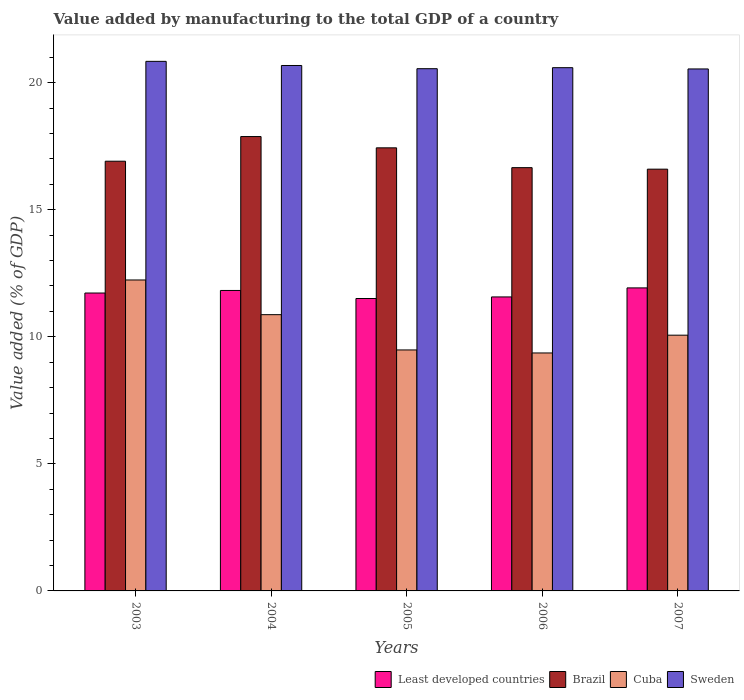How many different coloured bars are there?
Offer a very short reply. 4. Are the number of bars per tick equal to the number of legend labels?
Your answer should be very brief. Yes. Are the number of bars on each tick of the X-axis equal?
Provide a short and direct response. Yes. What is the label of the 4th group of bars from the left?
Provide a succinct answer. 2006. What is the value added by manufacturing to the total GDP in Brazil in 2006?
Provide a short and direct response. 16.65. Across all years, what is the maximum value added by manufacturing to the total GDP in Least developed countries?
Offer a terse response. 11.92. Across all years, what is the minimum value added by manufacturing to the total GDP in Sweden?
Provide a succinct answer. 20.54. What is the total value added by manufacturing to the total GDP in Least developed countries in the graph?
Your response must be concise. 58.54. What is the difference between the value added by manufacturing to the total GDP in Brazil in 2004 and that in 2006?
Provide a short and direct response. 1.22. What is the difference between the value added by manufacturing to the total GDP in Brazil in 2006 and the value added by manufacturing to the total GDP in Cuba in 2004?
Provide a succinct answer. 5.78. What is the average value added by manufacturing to the total GDP in Cuba per year?
Your answer should be very brief. 10.4. In the year 2007, what is the difference between the value added by manufacturing to the total GDP in Least developed countries and value added by manufacturing to the total GDP in Cuba?
Provide a short and direct response. 1.86. In how many years, is the value added by manufacturing to the total GDP in Cuba greater than 10 %?
Give a very brief answer. 3. What is the ratio of the value added by manufacturing to the total GDP in Cuba in 2005 to that in 2006?
Offer a terse response. 1.01. Is the value added by manufacturing to the total GDP in Cuba in 2005 less than that in 2007?
Ensure brevity in your answer.  Yes. What is the difference between the highest and the second highest value added by manufacturing to the total GDP in Sweden?
Give a very brief answer. 0.16. What is the difference between the highest and the lowest value added by manufacturing to the total GDP in Cuba?
Your answer should be compact. 2.87. In how many years, is the value added by manufacturing to the total GDP in Sweden greater than the average value added by manufacturing to the total GDP in Sweden taken over all years?
Give a very brief answer. 2. Is the sum of the value added by manufacturing to the total GDP in Least developed countries in 2003 and 2005 greater than the maximum value added by manufacturing to the total GDP in Brazil across all years?
Your answer should be very brief. Yes. What does the 3rd bar from the left in 2004 represents?
Offer a terse response. Cuba. What does the 4th bar from the right in 2006 represents?
Your answer should be compact. Least developed countries. Is it the case that in every year, the sum of the value added by manufacturing to the total GDP in Brazil and value added by manufacturing to the total GDP in Sweden is greater than the value added by manufacturing to the total GDP in Cuba?
Offer a terse response. Yes. How many bars are there?
Offer a very short reply. 20. Are the values on the major ticks of Y-axis written in scientific E-notation?
Your answer should be very brief. No. Does the graph contain grids?
Give a very brief answer. No. Where does the legend appear in the graph?
Your response must be concise. Bottom right. How many legend labels are there?
Offer a terse response. 4. How are the legend labels stacked?
Make the answer very short. Horizontal. What is the title of the graph?
Your response must be concise. Value added by manufacturing to the total GDP of a country. Does "Sierra Leone" appear as one of the legend labels in the graph?
Make the answer very short. No. What is the label or title of the Y-axis?
Your answer should be very brief. Value added (% of GDP). What is the Value added (% of GDP) in Least developed countries in 2003?
Ensure brevity in your answer.  11.72. What is the Value added (% of GDP) in Brazil in 2003?
Your response must be concise. 16.91. What is the Value added (% of GDP) in Cuba in 2003?
Make the answer very short. 12.23. What is the Value added (% of GDP) of Sweden in 2003?
Ensure brevity in your answer.  20.84. What is the Value added (% of GDP) of Least developed countries in 2004?
Provide a succinct answer. 11.82. What is the Value added (% of GDP) in Brazil in 2004?
Make the answer very short. 17.88. What is the Value added (% of GDP) of Cuba in 2004?
Ensure brevity in your answer.  10.87. What is the Value added (% of GDP) in Sweden in 2004?
Make the answer very short. 20.67. What is the Value added (% of GDP) of Least developed countries in 2005?
Provide a succinct answer. 11.51. What is the Value added (% of GDP) in Brazil in 2005?
Keep it short and to the point. 17.43. What is the Value added (% of GDP) in Cuba in 2005?
Ensure brevity in your answer.  9.48. What is the Value added (% of GDP) in Sweden in 2005?
Ensure brevity in your answer.  20.55. What is the Value added (% of GDP) in Least developed countries in 2006?
Offer a terse response. 11.57. What is the Value added (% of GDP) in Brazil in 2006?
Your answer should be compact. 16.65. What is the Value added (% of GDP) in Cuba in 2006?
Ensure brevity in your answer.  9.36. What is the Value added (% of GDP) of Sweden in 2006?
Keep it short and to the point. 20.59. What is the Value added (% of GDP) of Least developed countries in 2007?
Make the answer very short. 11.92. What is the Value added (% of GDP) in Brazil in 2007?
Keep it short and to the point. 16.59. What is the Value added (% of GDP) in Cuba in 2007?
Provide a succinct answer. 10.06. What is the Value added (% of GDP) of Sweden in 2007?
Offer a terse response. 20.54. Across all years, what is the maximum Value added (% of GDP) in Least developed countries?
Offer a very short reply. 11.92. Across all years, what is the maximum Value added (% of GDP) in Brazil?
Provide a succinct answer. 17.88. Across all years, what is the maximum Value added (% of GDP) in Cuba?
Make the answer very short. 12.23. Across all years, what is the maximum Value added (% of GDP) of Sweden?
Your response must be concise. 20.84. Across all years, what is the minimum Value added (% of GDP) of Least developed countries?
Provide a succinct answer. 11.51. Across all years, what is the minimum Value added (% of GDP) in Brazil?
Ensure brevity in your answer.  16.59. Across all years, what is the minimum Value added (% of GDP) in Cuba?
Your answer should be very brief. 9.36. Across all years, what is the minimum Value added (% of GDP) in Sweden?
Keep it short and to the point. 20.54. What is the total Value added (% of GDP) of Least developed countries in the graph?
Offer a terse response. 58.54. What is the total Value added (% of GDP) in Brazil in the graph?
Give a very brief answer. 85.46. What is the total Value added (% of GDP) in Cuba in the graph?
Keep it short and to the point. 52.01. What is the total Value added (% of GDP) of Sweden in the graph?
Keep it short and to the point. 103.18. What is the difference between the Value added (% of GDP) of Least developed countries in 2003 and that in 2004?
Give a very brief answer. -0.1. What is the difference between the Value added (% of GDP) in Brazil in 2003 and that in 2004?
Your answer should be very brief. -0.97. What is the difference between the Value added (% of GDP) in Cuba in 2003 and that in 2004?
Your answer should be compact. 1.36. What is the difference between the Value added (% of GDP) of Sweden in 2003 and that in 2004?
Give a very brief answer. 0.16. What is the difference between the Value added (% of GDP) in Least developed countries in 2003 and that in 2005?
Keep it short and to the point. 0.22. What is the difference between the Value added (% of GDP) in Brazil in 2003 and that in 2005?
Your response must be concise. -0.53. What is the difference between the Value added (% of GDP) in Cuba in 2003 and that in 2005?
Offer a very short reply. 2.75. What is the difference between the Value added (% of GDP) in Sweden in 2003 and that in 2005?
Offer a very short reply. 0.29. What is the difference between the Value added (% of GDP) in Least developed countries in 2003 and that in 2006?
Your answer should be very brief. 0.15. What is the difference between the Value added (% of GDP) in Brazil in 2003 and that in 2006?
Keep it short and to the point. 0.25. What is the difference between the Value added (% of GDP) in Cuba in 2003 and that in 2006?
Keep it short and to the point. 2.87. What is the difference between the Value added (% of GDP) of Sweden in 2003 and that in 2006?
Make the answer very short. 0.25. What is the difference between the Value added (% of GDP) of Least developed countries in 2003 and that in 2007?
Ensure brevity in your answer.  -0.2. What is the difference between the Value added (% of GDP) in Brazil in 2003 and that in 2007?
Make the answer very short. 0.31. What is the difference between the Value added (% of GDP) in Cuba in 2003 and that in 2007?
Provide a succinct answer. 2.17. What is the difference between the Value added (% of GDP) of Sweden in 2003 and that in 2007?
Ensure brevity in your answer.  0.3. What is the difference between the Value added (% of GDP) of Least developed countries in 2004 and that in 2005?
Provide a succinct answer. 0.32. What is the difference between the Value added (% of GDP) in Brazil in 2004 and that in 2005?
Make the answer very short. 0.44. What is the difference between the Value added (% of GDP) of Cuba in 2004 and that in 2005?
Offer a terse response. 1.39. What is the difference between the Value added (% of GDP) of Sweden in 2004 and that in 2005?
Keep it short and to the point. 0.13. What is the difference between the Value added (% of GDP) of Least developed countries in 2004 and that in 2006?
Provide a short and direct response. 0.25. What is the difference between the Value added (% of GDP) in Brazil in 2004 and that in 2006?
Keep it short and to the point. 1.22. What is the difference between the Value added (% of GDP) of Cuba in 2004 and that in 2006?
Keep it short and to the point. 1.51. What is the difference between the Value added (% of GDP) in Sweden in 2004 and that in 2006?
Ensure brevity in your answer.  0.09. What is the difference between the Value added (% of GDP) in Least developed countries in 2004 and that in 2007?
Ensure brevity in your answer.  -0.1. What is the difference between the Value added (% of GDP) in Brazil in 2004 and that in 2007?
Provide a succinct answer. 1.28. What is the difference between the Value added (% of GDP) in Cuba in 2004 and that in 2007?
Provide a succinct answer. 0.81. What is the difference between the Value added (% of GDP) of Sweden in 2004 and that in 2007?
Provide a succinct answer. 0.14. What is the difference between the Value added (% of GDP) of Least developed countries in 2005 and that in 2006?
Keep it short and to the point. -0.06. What is the difference between the Value added (% of GDP) in Brazil in 2005 and that in 2006?
Your response must be concise. 0.78. What is the difference between the Value added (% of GDP) in Cuba in 2005 and that in 2006?
Provide a short and direct response. 0.12. What is the difference between the Value added (% of GDP) of Sweden in 2005 and that in 2006?
Make the answer very short. -0.04. What is the difference between the Value added (% of GDP) in Least developed countries in 2005 and that in 2007?
Your answer should be very brief. -0.42. What is the difference between the Value added (% of GDP) of Brazil in 2005 and that in 2007?
Keep it short and to the point. 0.84. What is the difference between the Value added (% of GDP) in Cuba in 2005 and that in 2007?
Keep it short and to the point. -0.58. What is the difference between the Value added (% of GDP) of Sweden in 2005 and that in 2007?
Offer a terse response. 0.01. What is the difference between the Value added (% of GDP) of Least developed countries in 2006 and that in 2007?
Make the answer very short. -0.36. What is the difference between the Value added (% of GDP) of Brazil in 2006 and that in 2007?
Provide a short and direct response. 0.06. What is the difference between the Value added (% of GDP) of Cuba in 2006 and that in 2007?
Offer a terse response. -0.7. What is the difference between the Value added (% of GDP) in Sweden in 2006 and that in 2007?
Ensure brevity in your answer.  0.05. What is the difference between the Value added (% of GDP) of Least developed countries in 2003 and the Value added (% of GDP) of Brazil in 2004?
Provide a short and direct response. -6.16. What is the difference between the Value added (% of GDP) of Least developed countries in 2003 and the Value added (% of GDP) of Cuba in 2004?
Make the answer very short. 0.85. What is the difference between the Value added (% of GDP) of Least developed countries in 2003 and the Value added (% of GDP) of Sweden in 2004?
Your response must be concise. -8.95. What is the difference between the Value added (% of GDP) in Brazil in 2003 and the Value added (% of GDP) in Cuba in 2004?
Provide a short and direct response. 6.04. What is the difference between the Value added (% of GDP) of Brazil in 2003 and the Value added (% of GDP) of Sweden in 2004?
Offer a very short reply. -3.77. What is the difference between the Value added (% of GDP) in Cuba in 2003 and the Value added (% of GDP) in Sweden in 2004?
Offer a terse response. -8.44. What is the difference between the Value added (% of GDP) of Least developed countries in 2003 and the Value added (% of GDP) of Brazil in 2005?
Keep it short and to the point. -5.71. What is the difference between the Value added (% of GDP) of Least developed countries in 2003 and the Value added (% of GDP) of Cuba in 2005?
Your response must be concise. 2.24. What is the difference between the Value added (% of GDP) in Least developed countries in 2003 and the Value added (% of GDP) in Sweden in 2005?
Make the answer very short. -8.83. What is the difference between the Value added (% of GDP) in Brazil in 2003 and the Value added (% of GDP) in Cuba in 2005?
Keep it short and to the point. 7.43. What is the difference between the Value added (% of GDP) of Brazil in 2003 and the Value added (% of GDP) of Sweden in 2005?
Your answer should be compact. -3.64. What is the difference between the Value added (% of GDP) of Cuba in 2003 and the Value added (% of GDP) of Sweden in 2005?
Keep it short and to the point. -8.31. What is the difference between the Value added (% of GDP) of Least developed countries in 2003 and the Value added (% of GDP) of Brazil in 2006?
Keep it short and to the point. -4.93. What is the difference between the Value added (% of GDP) in Least developed countries in 2003 and the Value added (% of GDP) in Cuba in 2006?
Provide a succinct answer. 2.36. What is the difference between the Value added (% of GDP) of Least developed countries in 2003 and the Value added (% of GDP) of Sweden in 2006?
Offer a terse response. -8.87. What is the difference between the Value added (% of GDP) of Brazil in 2003 and the Value added (% of GDP) of Cuba in 2006?
Keep it short and to the point. 7.54. What is the difference between the Value added (% of GDP) in Brazil in 2003 and the Value added (% of GDP) in Sweden in 2006?
Your answer should be very brief. -3.68. What is the difference between the Value added (% of GDP) in Cuba in 2003 and the Value added (% of GDP) in Sweden in 2006?
Ensure brevity in your answer.  -8.35. What is the difference between the Value added (% of GDP) in Least developed countries in 2003 and the Value added (% of GDP) in Brazil in 2007?
Provide a short and direct response. -4.87. What is the difference between the Value added (% of GDP) in Least developed countries in 2003 and the Value added (% of GDP) in Cuba in 2007?
Ensure brevity in your answer.  1.66. What is the difference between the Value added (% of GDP) in Least developed countries in 2003 and the Value added (% of GDP) in Sweden in 2007?
Make the answer very short. -8.82. What is the difference between the Value added (% of GDP) of Brazil in 2003 and the Value added (% of GDP) of Cuba in 2007?
Provide a short and direct response. 6.84. What is the difference between the Value added (% of GDP) in Brazil in 2003 and the Value added (% of GDP) in Sweden in 2007?
Provide a succinct answer. -3.63. What is the difference between the Value added (% of GDP) in Cuba in 2003 and the Value added (% of GDP) in Sweden in 2007?
Your answer should be compact. -8.3. What is the difference between the Value added (% of GDP) in Least developed countries in 2004 and the Value added (% of GDP) in Brazil in 2005?
Provide a succinct answer. -5.61. What is the difference between the Value added (% of GDP) in Least developed countries in 2004 and the Value added (% of GDP) in Cuba in 2005?
Give a very brief answer. 2.34. What is the difference between the Value added (% of GDP) of Least developed countries in 2004 and the Value added (% of GDP) of Sweden in 2005?
Make the answer very short. -8.73. What is the difference between the Value added (% of GDP) of Brazil in 2004 and the Value added (% of GDP) of Cuba in 2005?
Your answer should be compact. 8.4. What is the difference between the Value added (% of GDP) of Brazil in 2004 and the Value added (% of GDP) of Sweden in 2005?
Provide a short and direct response. -2.67. What is the difference between the Value added (% of GDP) in Cuba in 2004 and the Value added (% of GDP) in Sweden in 2005?
Offer a very short reply. -9.68. What is the difference between the Value added (% of GDP) of Least developed countries in 2004 and the Value added (% of GDP) of Brazil in 2006?
Your response must be concise. -4.83. What is the difference between the Value added (% of GDP) in Least developed countries in 2004 and the Value added (% of GDP) in Cuba in 2006?
Ensure brevity in your answer.  2.46. What is the difference between the Value added (% of GDP) in Least developed countries in 2004 and the Value added (% of GDP) in Sweden in 2006?
Ensure brevity in your answer.  -8.77. What is the difference between the Value added (% of GDP) in Brazil in 2004 and the Value added (% of GDP) in Cuba in 2006?
Ensure brevity in your answer.  8.51. What is the difference between the Value added (% of GDP) in Brazil in 2004 and the Value added (% of GDP) in Sweden in 2006?
Your answer should be very brief. -2.71. What is the difference between the Value added (% of GDP) of Cuba in 2004 and the Value added (% of GDP) of Sweden in 2006?
Ensure brevity in your answer.  -9.72. What is the difference between the Value added (% of GDP) of Least developed countries in 2004 and the Value added (% of GDP) of Brazil in 2007?
Give a very brief answer. -4.77. What is the difference between the Value added (% of GDP) of Least developed countries in 2004 and the Value added (% of GDP) of Cuba in 2007?
Offer a terse response. 1.76. What is the difference between the Value added (% of GDP) of Least developed countries in 2004 and the Value added (% of GDP) of Sweden in 2007?
Make the answer very short. -8.72. What is the difference between the Value added (% of GDP) in Brazil in 2004 and the Value added (% of GDP) in Cuba in 2007?
Provide a succinct answer. 7.81. What is the difference between the Value added (% of GDP) in Brazil in 2004 and the Value added (% of GDP) in Sweden in 2007?
Provide a succinct answer. -2.66. What is the difference between the Value added (% of GDP) of Cuba in 2004 and the Value added (% of GDP) of Sweden in 2007?
Offer a very short reply. -9.67. What is the difference between the Value added (% of GDP) of Least developed countries in 2005 and the Value added (% of GDP) of Brazil in 2006?
Your answer should be very brief. -5.15. What is the difference between the Value added (% of GDP) of Least developed countries in 2005 and the Value added (% of GDP) of Cuba in 2006?
Your response must be concise. 2.14. What is the difference between the Value added (% of GDP) of Least developed countries in 2005 and the Value added (% of GDP) of Sweden in 2006?
Your response must be concise. -9.08. What is the difference between the Value added (% of GDP) of Brazil in 2005 and the Value added (% of GDP) of Cuba in 2006?
Give a very brief answer. 8.07. What is the difference between the Value added (% of GDP) of Brazil in 2005 and the Value added (% of GDP) of Sweden in 2006?
Offer a very short reply. -3.15. What is the difference between the Value added (% of GDP) of Cuba in 2005 and the Value added (% of GDP) of Sweden in 2006?
Your answer should be very brief. -11.11. What is the difference between the Value added (% of GDP) in Least developed countries in 2005 and the Value added (% of GDP) in Brazil in 2007?
Make the answer very short. -5.09. What is the difference between the Value added (% of GDP) in Least developed countries in 2005 and the Value added (% of GDP) in Cuba in 2007?
Give a very brief answer. 1.44. What is the difference between the Value added (% of GDP) in Least developed countries in 2005 and the Value added (% of GDP) in Sweden in 2007?
Give a very brief answer. -9.03. What is the difference between the Value added (% of GDP) of Brazil in 2005 and the Value added (% of GDP) of Cuba in 2007?
Provide a short and direct response. 7.37. What is the difference between the Value added (% of GDP) in Brazil in 2005 and the Value added (% of GDP) in Sweden in 2007?
Your answer should be compact. -3.1. What is the difference between the Value added (% of GDP) in Cuba in 2005 and the Value added (% of GDP) in Sweden in 2007?
Your answer should be very brief. -11.06. What is the difference between the Value added (% of GDP) of Least developed countries in 2006 and the Value added (% of GDP) of Brazil in 2007?
Offer a terse response. -5.03. What is the difference between the Value added (% of GDP) of Least developed countries in 2006 and the Value added (% of GDP) of Cuba in 2007?
Make the answer very short. 1.51. What is the difference between the Value added (% of GDP) in Least developed countries in 2006 and the Value added (% of GDP) in Sweden in 2007?
Make the answer very short. -8.97. What is the difference between the Value added (% of GDP) in Brazil in 2006 and the Value added (% of GDP) in Cuba in 2007?
Offer a terse response. 6.59. What is the difference between the Value added (% of GDP) in Brazil in 2006 and the Value added (% of GDP) in Sweden in 2007?
Ensure brevity in your answer.  -3.88. What is the difference between the Value added (% of GDP) of Cuba in 2006 and the Value added (% of GDP) of Sweden in 2007?
Give a very brief answer. -11.17. What is the average Value added (% of GDP) of Least developed countries per year?
Your answer should be compact. 11.71. What is the average Value added (% of GDP) of Brazil per year?
Provide a short and direct response. 17.09. What is the average Value added (% of GDP) in Cuba per year?
Offer a terse response. 10.4. What is the average Value added (% of GDP) in Sweden per year?
Offer a very short reply. 20.64. In the year 2003, what is the difference between the Value added (% of GDP) in Least developed countries and Value added (% of GDP) in Brazil?
Your answer should be very brief. -5.19. In the year 2003, what is the difference between the Value added (% of GDP) in Least developed countries and Value added (% of GDP) in Cuba?
Offer a terse response. -0.51. In the year 2003, what is the difference between the Value added (% of GDP) of Least developed countries and Value added (% of GDP) of Sweden?
Provide a succinct answer. -9.12. In the year 2003, what is the difference between the Value added (% of GDP) in Brazil and Value added (% of GDP) in Cuba?
Your answer should be compact. 4.67. In the year 2003, what is the difference between the Value added (% of GDP) in Brazil and Value added (% of GDP) in Sweden?
Provide a succinct answer. -3.93. In the year 2003, what is the difference between the Value added (% of GDP) in Cuba and Value added (% of GDP) in Sweden?
Offer a very short reply. -8.6. In the year 2004, what is the difference between the Value added (% of GDP) in Least developed countries and Value added (% of GDP) in Brazil?
Provide a short and direct response. -6.05. In the year 2004, what is the difference between the Value added (% of GDP) of Least developed countries and Value added (% of GDP) of Cuba?
Your answer should be compact. 0.95. In the year 2004, what is the difference between the Value added (% of GDP) of Least developed countries and Value added (% of GDP) of Sweden?
Make the answer very short. -8.85. In the year 2004, what is the difference between the Value added (% of GDP) in Brazil and Value added (% of GDP) in Cuba?
Keep it short and to the point. 7.01. In the year 2004, what is the difference between the Value added (% of GDP) of Brazil and Value added (% of GDP) of Sweden?
Provide a succinct answer. -2.8. In the year 2004, what is the difference between the Value added (% of GDP) of Cuba and Value added (% of GDP) of Sweden?
Offer a very short reply. -9.8. In the year 2005, what is the difference between the Value added (% of GDP) of Least developed countries and Value added (% of GDP) of Brazil?
Your answer should be very brief. -5.93. In the year 2005, what is the difference between the Value added (% of GDP) of Least developed countries and Value added (% of GDP) of Cuba?
Keep it short and to the point. 2.02. In the year 2005, what is the difference between the Value added (% of GDP) of Least developed countries and Value added (% of GDP) of Sweden?
Make the answer very short. -9.04. In the year 2005, what is the difference between the Value added (% of GDP) of Brazil and Value added (% of GDP) of Cuba?
Your answer should be very brief. 7.95. In the year 2005, what is the difference between the Value added (% of GDP) of Brazil and Value added (% of GDP) of Sweden?
Your answer should be compact. -3.11. In the year 2005, what is the difference between the Value added (% of GDP) in Cuba and Value added (% of GDP) in Sweden?
Your answer should be very brief. -11.07. In the year 2006, what is the difference between the Value added (% of GDP) in Least developed countries and Value added (% of GDP) in Brazil?
Your answer should be compact. -5.09. In the year 2006, what is the difference between the Value added (% of GDP) of Least developed countries and Value added (% of GDP) of Cuba?
Your response must be concise. 2.2. In the year 2006, what is the difference between the Value added (% of GDP) in Least developed countries and Value added (% of GDP) in Sweden?
Offer a terse response. -9.02. In the year 2006, what is the difference between the Value added (% of GDP) of Brazil and Value added (% of GDP) of Cuba?
Your answer should be very brief. 7.29. In the year 2006, what is the difference between the Value added (% of GDP) in Brazil and Value added (% of GDP) in Sweden?
Provide a short and direct response. -3.93. In the year 2006, what is the difference between the Value added (% of GDP) of Cuba and Value added (% of GDP) of Sweden?
Give a very brief answer. -11.22. In the year 2007, what is the difference between the Value added (% of GDP) in Least developed countries and Value added (% of GDP) in Brazil?
Your answer should be very brief. -4.67. In the year 2007, what is the difference between the Value added (% of GDP) in Least developed countries and Value added (% of GDP) in Cuba?
Ensure brevity in your answer.  1.86. In the year 2007, what is the difference between the Value added (% of GDP) of Least developed countries and Value added (% of GDP) of Sweden?
Provide a succinct answer. -8.61. In the year 2007, what is the difference between the Value added (% of GDP) in Brazil and Value added (% of GDP) in Cuba?
Offer a very short reply. 6.53. In the year 2007, what is the difference between the Value added (% of GDP) in Brazil and Value added (% of GDP) in Sweden?
Give a very brief answer. -3.94. In the year 2007, what is the difference between the Value added (% of GDP) in Cuba and Value added (% of GDP) in Sweden?
Offer a terse response. -10.47. What is the ratio of the Value added (% of GDP) in Brazil in 2003 to that in 2004?
Keep it short and to the point. 0.95. What is the ratio of the Value added (% of GDP) in Cuba in 2003 to that in 2004?
Offer a very short reply. 1.13. What is the ratio of the Value added (% of GDP) of Sweden in 2003 to that in 2004?
Your response must be concise. 1.01. What is the ratio of the Value added (% of GDP) of Least developed countries in 2003 to that in 2005?
Give a very brief answer. 1.02. What is the ratio of the Value added (% of GDP) in Brazil in 2003 to that in 2005?
Keep it short and to the point. 0.97. What is the ratio of the Value added (% of GDP) in Cuba in 2003 to that in 2005?
Offer a terse response. 1.29. What is the ratio of the Value added (% of GDP) of Sweden in 2003 to that in 2005?
Provide a short and direct response. 1.01. What is the ratio of the Value added (% of GDP) of Least developed countries in 2003 to that in 2006?
Your response must be concise. 1.01. What is the ratio of the Value added (% of GDP) of Brazil in 2003 to that in 2006?
Offer a terse response. 1.02. What is the ratio of the Value added (% of GDP) of Cuba in 2003 to that in 2006?
Ensure brevity in your answer.  1.31. What is the ratio of the Value added (% of GDP) in Sweden in 2003 to that in 2006?
Offer a very short reply. 1.01. What is the ratio of the Value added (% of GDP) of Least developed countries in 2003 to that in 2007?
Offer a very short reply. 0.98. What is the ratio of the Value added (% of GDP) in Brazil in 2003 to that in 2007?
Provide a short and direct response. 1.02. What is the ratio of the Value added (% of GDP) in Cuba in 2003 to that in 2007?
Keep it short and to the point. 1.22. What is the ratio of the Value added (% of GDP) in Sweden in 2003 to that in 2007?
Your answer should be very brief. 1.01. What is the ratio of the Value added (% of GDP) of Least developed countries in 2004 to that in 2005?
Provide a succinct answer. 1.03. What is the ratio of the Value added (% of GDP) in Brazil in 2004 to that in 2005?
Your answer should be very brief. 1.03. What is the ratio of the Value added (% of GDP) of Cuba in 2004 to that in 2005?
Offer a very short reply. 1.15. What is the ratio of the Value added (% of GDP) in Sweden in 2004 to that in 2005?
Give a very brief answer. 1.01. What is the ratio of the Value added (% of GDP) of Least developed countries in 2004 to that in 2006?
Offer a terse response. 1.02. What is the ratio of the Value added (% of GDP) in Brazil in 2004 to that in 2006?
Your answer should be compact. 1.07. What is the ratio of the Value added (% of GDP) in Cuba in 2004 to that in 2006?
Your answer should be compact. 1.16. What is the ratio of the Value added (% of GDP) in Brazil in 2004 to that in 2007?
Your answer should be very brief. 1.08. What is the ratio of the Value added (% of GDP) in Cuba in 2004 to that in 2007?
Make the answer very short. 1.08. What is the ratio of the Value added (% of GDP) in Sweden in 2004 to that in 2007?
Provide a short and direct response. 1.01. What is the ratio of the Value added (% of GDP) in Least developed countries in 2005 to that in 2006?
Provide a succinct answer. 0.99. What is the ratio of the Value added (% of GDP) of Brazil in 2005 to that in 2006?
Give a very brief answer. 1.05. What is the ratio of the Value added (% of GDP) in Cuba in 2005 to that in 2006?
Your answer should be compact. 1.01. What is the ratio of the Value added (% of GDP) of Sweden in 2005 to that in 2006?
Your response must be concise. 1. What is the ratio of the Value added (% of GDP) of Brazil in 2005 to that in 2007?
Ensure brevity in your answer.  1.05. What is the ratio of the Value added (% of GDP) of Cuba in 2005 to that in 2007?
Provide a short and direct response. 0.94. What is the ratio of the Value added (% of GDP) of Sweden in 2005 to that in 2007?
Give a very brief answer. 1. What is the ratio of the Value added (% of GDP) of Least developed countries in 2006 to that in 2007?
Provide a succinct answer. 0.97. What is the ratio of the Value added (% of GDP) of Cuba in 2006 to that in 2007?
Keep it short and to the point. 0.93. What is the difference between the highest and the second highest Value added (% of GDP) in Least developed countries?
Provide a short and direct response. 0.1. What is the difference between the highest and the second highest Value added (% of GDP) of Brazil?
Your answer should be very brief. 0.44. What is the difference between the highest and the second highest Value added (% of GDP) of Cuba?
Give a very brief answer. 1.36. What is the difference between the highest and the second highest Value added (% of GDP) of Sweden?
Make the answer very short. 0.16. What is the difference between the highest and the lowest Value added (% of GDP) of Least developed countries?
Give a very brief answer. 0.42. What is the difference between the highest and the lowest Value added (% of GDP) in Brazil?
Make the answer very short. 1.28. What is the difference between the highest and the lowest Value added (% of GDP) of Cuba?
Provide a succinct answer. 2.87. What is the difference between the highest and the lowest Value added (% of GDP) in Sweden?
Your answer should be very brief. 0.3. 